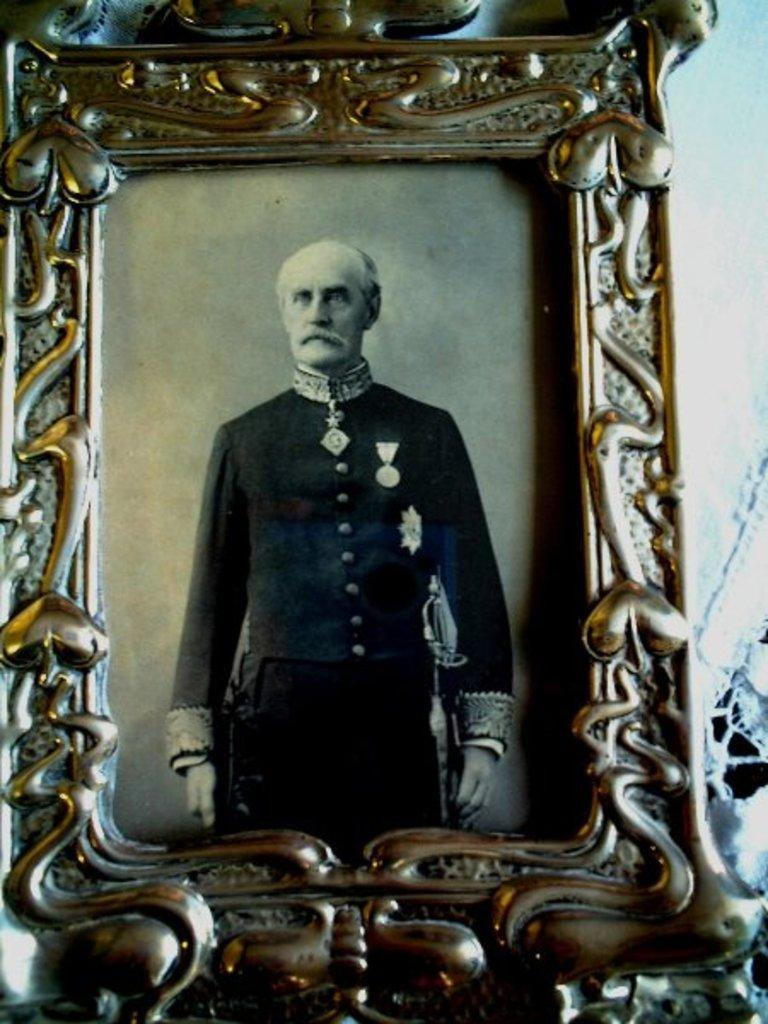What is the main object in the image? There is a frame in the image. What is depicted within the frame? The frame contains a photo of a man. What can be seen on the right side of the image? There is a wall visible on the right side of the image. What type of lock is used to secure the pipe in the image? There is no lock or pipe present in the image; it only features a frame with a photo of a man and a wall on the right side. 